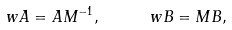Convert formula to latex. <formula><loc_0><loc_0><loc_500><loc_500>\ w A = A M ^ { - 1 } , \quad \ w B = M B ,</formula> 